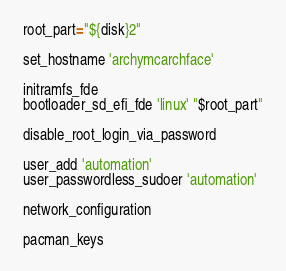Convert code to text. <code><loc_0><loc_0><loc_500><loc_500><_Bash_>root_part="${disk}2"

set_hostname 'archymcarchface'

initramfs_fde
bootloader_sd_efi_fde 'linux' "$root_part"

disable_root_login_via_password

user_add 'automation'
user_passwordless_sudoer 'automation'

network_configuration

pacman_keys
</code> 